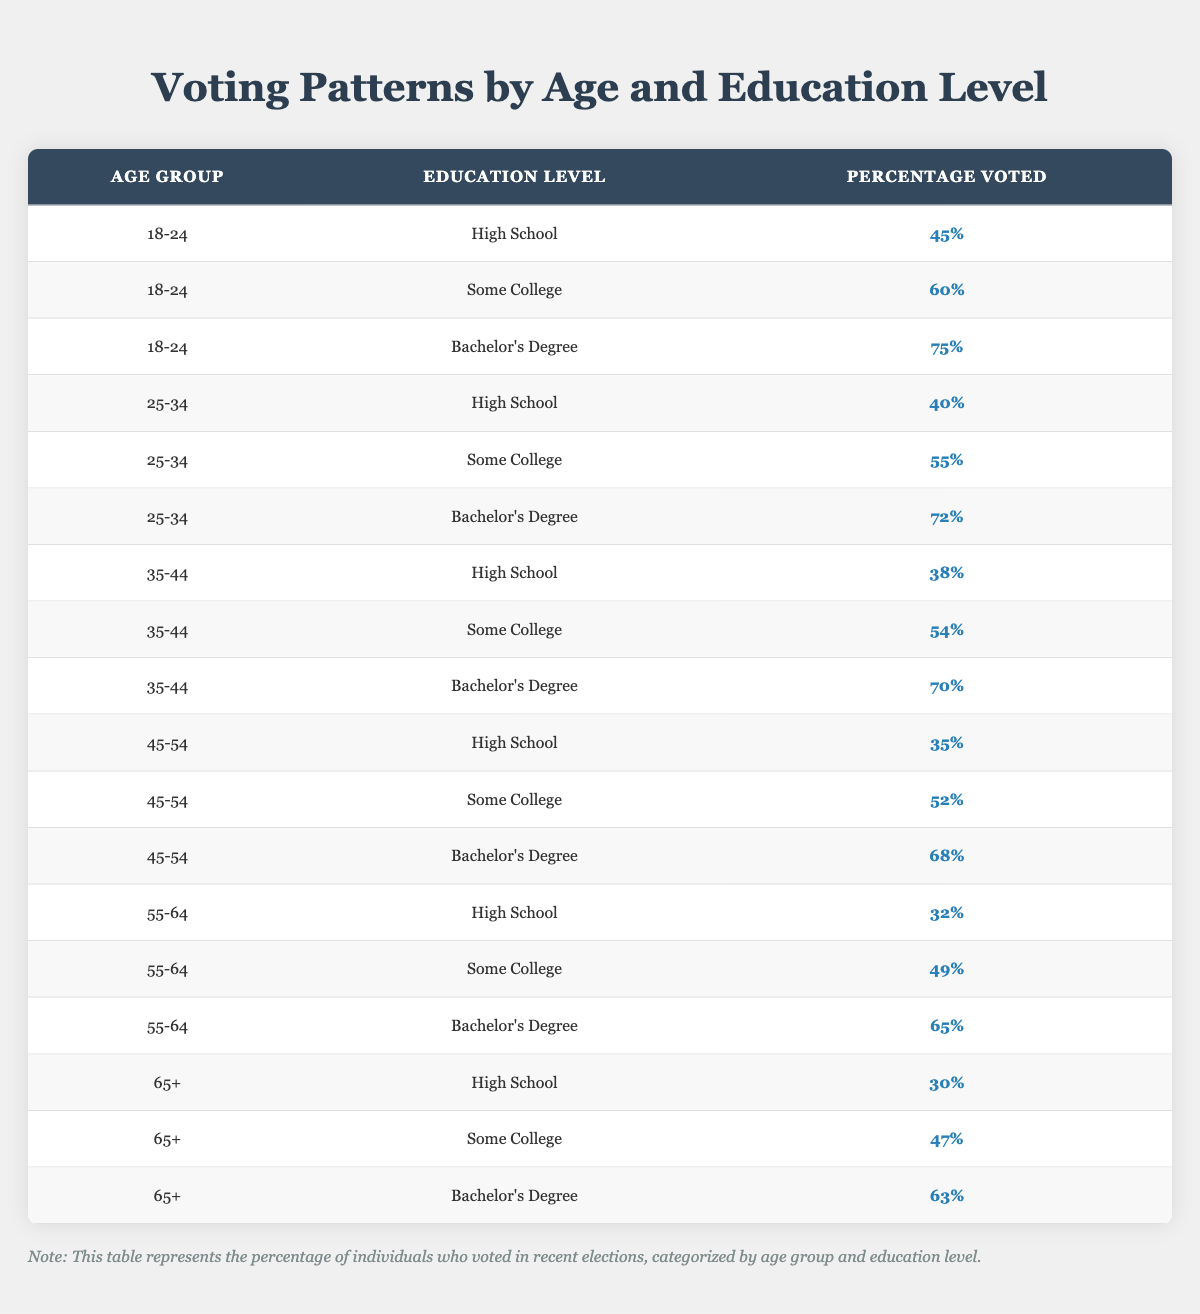What is the percentage of 18-24 year-olds with a Bachelor's degree who voted? The table lists the percentage for the age group 18-24 with a Bachelor's Degree as 75%.
Answer: 75% What is the percentage of voters aged 25-34 who completed High School? From the table, the percentage for the age group 25-34 with a High School education is 40%.
Answer: 40% True or False: The percentage of voters aged 45-54 with a Bachelor's degree is greater than that of those aged 65+ with a Bachelor's degree. The table shows that 68% of the 45-54 age group voted with a Bachelor's degree, while 63% of the 65+ age group did. Since 68% is greater than 63%, this statement is true.
Answer: True What is the average percentage of voters across all age groups who had some college education? To find the average for those with some college, we need to sum their percentages: 60% + 55% + 54% + 52% + 49% + 47% = 317%. Since there are 6 age groups listed, we calculate the average as 317% / 6 = 52.83%.
Answer: Approximately 52.83% How does the percentage of voters aged 55-64 with a Bachelor's degree compare to those aged 35-44 with a Bachelor's degree? The table shows that the percentage for the 55-64 age group with a Bachelor's degree is 65%, while the percentage for the 35-44 age group is 70%. Since 65% is less than 70%, we conclude that the 55-64 group has a lower percentage.
Answer: Lower 